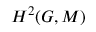<formula> <loc_0><loc_0><loc_500><loc_500>H ^ { 2 } ( G , M )</formula> 